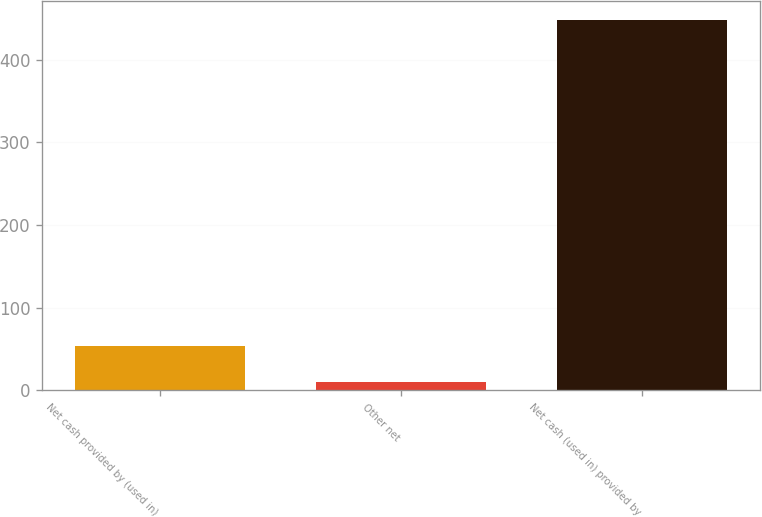<chart> <loc_0><loc_0><loc_500><loc_500><bar_chart><fcel>Net cash provided by (used in)<fcel>Other net<fcel>Net cash (used in) provided by<nl><fcel>53.8<fcel>10<fcel>448<nl></chart> 